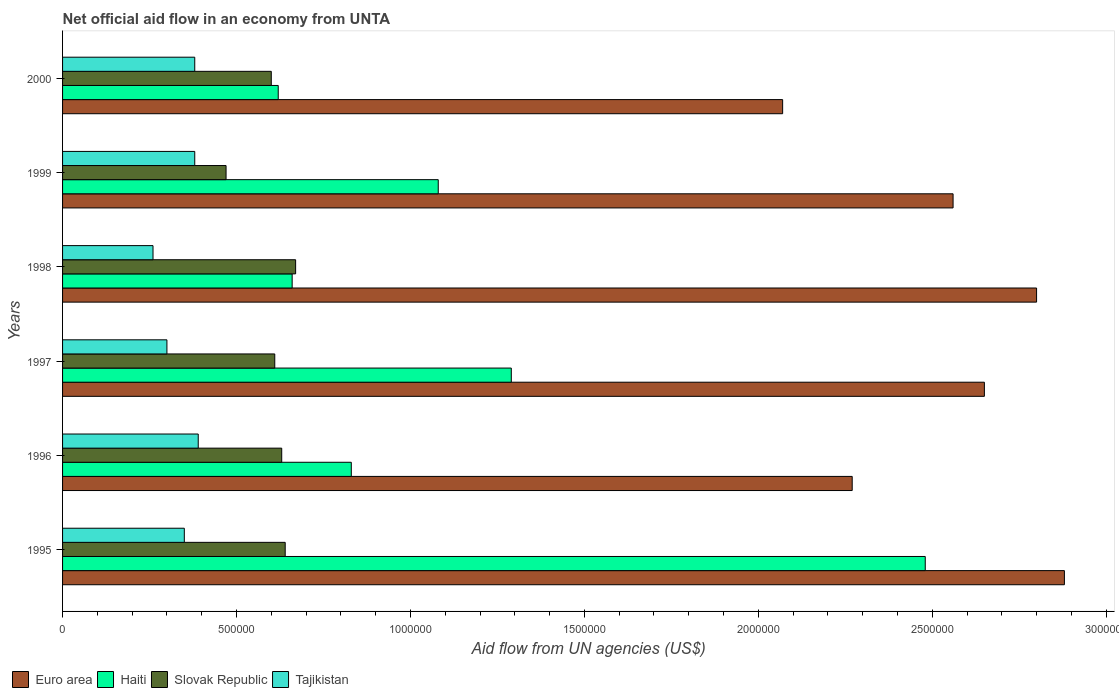How many different coloured bars are there?
Offer a terse response. 4. How many groups of bars are there?
Give a very brief answer. 6. Are the number of bars per tick equal to the number of legend labels?
Offer a very short reply. Yes. How many bars are there on the 4th tick from the top?
Your answer should be very brief. 4. How many bars are there on the 6th tick from the bottom?
Your answer should be compact. 4. What is the label of the 2nd group of bars from the top?
Your answer should be compact. 1999. What is the net official aid flow in Haiti in 1995?
Offer a terse response. 2.48e+06. Across all years, what is the maximum net official aid flow in Tajikistan?
Give a very brief answer. 3.90e+05. Across all years, what is the minimum net official aid flow in Haiti?
Offer a very short reply. 6.20e+05. In which year was the net official aid flow in Haiti maximum?
Keep it short and to the point. 1995. What is the total net official aid flow in Slovak Republic in the graph?
Offer a very short reply. 3.62e+06. What is the difference between the net official aid flow in Euro area in 1996 and the net official aid flow in Haiti in 1998?
Provide a succinct answer. 1.61e+06. What is the average net official aid flow in Tajikistan per year?
Offer a very short reply. 3.43e+05. What is the ratio of the net official aid flow in Slovak Republic in 1998 to that in 2000?
Ensure brevity in your answer.  1.12. What is the difference between the highest and the second highest net official aid flow in Euro area?
Offer a terse response. 8.00e+04. What is the difference between the highest and the lowest net official aid flow in Tajikistan?
Give a very brief answer. 1.30e+05. Is the sum of the net official aid flow in Slovak Republic in 1995 and 1998 greater than the maximum net official aid flow in Haiti across all years?
Ensure brevity in your answer.  No. Is it the case that in every year, the sum of the net official aid flow in Slovak Republic and net official aid flow in Tajikistan is greater than the sum of net official aid flow in Euro area and net official aid flow in Haiti?
Make the answer very short. Yes. What does the 3rd bar from the top in 1999 represents?
Provide a short and direct response. Haiti. What does the 4th bar from the bottom in 2000 represents?
Keep it short and to the point. Tajikistan. What is the difference between two consecutive major ticks on the X-axis?
Ensure brevity in your answer.  5.00e+05. Does the graph contain any zero values?
Your response must be concise. No. How are the legend labels stacked?
Keep it short and to the point. Horizontal. What is the title of the graph?
Provide a short and direct response. Net official aid flow in an economy from UNTA. Does "Malta" appear as one of the legend labels in the graph?
Make the answer very short. No. What is the label or title of the X-axis?
Your answer should be very brief. Aid flow from UN agencies (US$). What is the Aid flow from UN agencies (US$) in Euro area in 1995?
Provide a short and direct response. 2.88e+06. What is the Aid flow from UN agencies (US$) in Haiti in 1995?
Give a very brief answer. 2.48e+06. What is the Aid flow from UN agencies (US$) of Slovak Republic in 1995?
Provide a short and direct response. 6.40e+05. What is the Aid flow from UN agencies (US$) of Euro area in 1996?
Make the answer very short. 2.27e+06. What is the Aid flow from UN agencies (US$) in Haiti in 1996?
Offer a terse response. 8.30e+05. What is the Aid flow from UN agencies (US$) of Slovak Republic in 1996?
Provide a succinct answer. 6.30e+05. What is the Aid flow from UN agencies (US$) of Tajikistan in 1996?
Keep it short and to the point. 3.90e+05. What is the Aid flow from UN agencies (US$) of Euro area in 1997?
Provide a short and direct response. 2.65e+06. What is the Aid flow from UN agencies (US$) in Haiti in 1997?
Your answer should be very brief. 1.29e+06. What is the Aid flow from UN agencies (US$) in Tajikistan in 1997?
Make the answer very short. 3.00e+05. What is the Aid flow from UN agencies (US$) in Euro area in 1998?
Give a very brief answer. 2.80e+06. What is the Aid flow from UN agencies (US$) in Slovak Republic in 1998?
Your answer should be compact. 6.70e+05. What is the Aid flow from UN agencies (US$) of Tajikistan in 1998?
Your response must be concise. 2.60e+05. What is the Aid flow from UN agencies (US$) of Euro area in 1999?
Make the answer very short. 2.56e+06. What is the Aid flow from UN agencies (US$) of Haiti in 1999?
Give a very brief answer. 1.08e+06. What is the Aid flow from UN agencies (US$) in Slovak Republic in 1999?
Your answer should be very brief. 4.70e+05. What is the Aid flow from UN agencies (US$) in Euro area in 2000?
Your answer should be very brief. 2.07e+06. What is the Aid flow from UN agencies (US$) of Haiti in 2000?
Make the answer very short. 6.20e+05. Across all years, what is the maximum Aid flow from UN agencies (US$) of Euro area?
Offer a terse response. 2.88e+06. Across all years, what is the maximum Aid flow from UN agencies (US$) in Haiti?
Keep it short and to the point. 2.48e+06. Across all years, what is the maximum Aid flow from UN agencies (US$) of Slovak Republic?
Give a very brief answer. 6.70e+05. Across all years, what is the maximum Aid flow from UN agencies (US$) in Tajikistan?
Keep it short and to the point. 3.90e+05. Across all years, what is the minimum Aid flow from UN agencies (US$) in Euro area?
Offer a very short reply. 2.07e+06. Across all years, what is the minimum Aid flow from UN agencies (US$) in Haiti?
Make the answer very short. 6.20e+05. Across all years, what is the minimum Aid flow from UN agencies (US$) in Slovak Republic?
Keep it short and to the point. 4.70e+05. What is the total Aid flow from UN agencies (US$) in Euro area in the graph?
Your response must be concise. 1.52e+07. What is the total Aid flow from UN agencies (US$) in Haiti in the graph?
Your answer should be very brief. 6.96e+06. What is the total Aid flow from UN agencies (US$) of Slovak Republic in the graph?
Your answer should be compact. 3.62e+06. What is the total Aid flow from UN agencies (US$) in Tajikistan in the graph?
Your response must be concise. 2.06e+06. What is the difference between the Aid flow from UN agencies (US$) in Haiti in 1995 and that in 1996?
Your answer should be compact. 1.65e+06. What is the difference between the Aid flow from UN agencies (US$) of Euro area in 1995 and that in 1997?
Give a very brief answer. 2.30e+05. What is the difference between the Aid flow from UN agencies (US$) in Haiti in 1995 and that in 1997?
Offer a very short reply. 1.19e+06. What is the difference between the Aid flow from UN agencies (US$) in Tajikistan in 1995 and that in 1997?
Offer a terse response. 5.00e+04. What is the difference between the Aid flow from UN agencies (US$) of Haiti in 1995 and that in 1998?
Your answer should be very brief. 1.82e+06. What is the difference between the Aid flow from UN agencies (US$) of Euro area in 1995 and that in 1999?
Offer a terse response. 3.20e+05. What is the difference between the Aid flow from UN agencies (US$) in Haiti in 1995 and that in 1999?
Keep it short and to the point. 1.40e+06. What is the difference between the Aid flow from UN agencies (US$) of Slovak Republic in 1995 and that in 1999?
Your response must be concise. 1.70e+05. What is the difference between the Aid flow from UN agencies (US$) of Euro area in 1995 and that in 2000?
Make the answer very short. 8.10e+05. What is the difference between the Aid flow from UN agencies (US$) in Haiti in 1995 and that in 2000?
Your answer should be very brief. 1.86e+06. What is the difference between the Aid flow from UN agencies (US$) in Euro area in 1996 and that in 1997?
Your answer should be very brief. -3.80e+05. What is the difference between the Aid flow from UN agencies (US$) of Haiti in 1996 and that in 1997?
Offer a terse response. -4.60e+05. What is the difference between the Aid flow from UN agencies (US$) of Euro area in 1996 and that in 1998?
Give a very brief answer. -5.30e+05. What is the difference between the Aid flow from UN agencies (US$) in Haiti in 1996 and that in 1999?
Keep it short and to the point. -2.50e+05. What is the difference between the Aid flow from UN agencies (US$) in Tajikistan in 1996 and that in 1999?
Provide a succinct answer. 10000. What is the difference between the Aid flow from UN agencies (US$) in Slovak Republic in 1996 and that in 2000?
Offer a terse response. 3.00e+04. What is the difference between the Aid flow from UN agencies (US$) in Tajikistan in 1996 and that in 2000?
Offer a very short reply. 10000. What is the difference between the Aid flow from UN agencies (US$) of Euro area in 1997 and that in 1998?
Offer a terse response. -1.50e+05. What is the difference between the Aid flow from UN agencies (US$) in Haiti in 1997 and that in 1998?
Keep it short and to the point. 6.30e+05. What is the difference between the Aid flow from UN agencies (US$) of Slovak Republic in 1997 and that in 1998?
Provide a short and direct response. -6.00e+04. What is the difference between the Aid flow from UN agencies (US$) in Tajikistan in 1997 and that in 1998?
Offer a very short reply. 4.00e+04. What is the difference between the Aid flow from UN agencies (US$) in Euro area in 1997 and that in 1999?
Provide a succinct answer. 9.00e+04. What is the difference between the Aid flow from UN agencies (US$) in Haiti in 1997 and that in 1999?
Give a very brief answer. 2.10e+05. What is the difference between the Aid flow from UN agencies (US$) in Slovak Republic in 1997 and that in 1999?
Offer a very short reply. 1.40e+05. What is the difference between the Aid flow from UN agencies (US$) in Euro area in 1997 and that in 2000?
Keep it short and to the point. 5.80e+05. What is the difference between the Aid flow from UN agencies (US$) in Haiti in 1997 and that in 2000?
Your answer should be compact. 6.70e+05. What is the difference between the Aid flow from UN agencies (US$) of Slovak Republic in 1997 and that in 2000?
Ensure brevity in your answer.  10000. What is the difference between the Aid flow from UN agencies (US$) in Tajikistan in 1997 and that in 2000?
Provide a short and direct response. -8.00e+04. What is the difference between the Aid flow from UN agencies (US$) of Haiti in 1998 and that in 1999?
Make the answer very short. -4.20e+05. What is the difference between the Aid flow from UN agencies (US$) of Slovak Republic in 1998 and that in 1999?
Give a very brief answer. 2.00e+05. What is the difference between the Aid flow from UN agencies (US$) in Tajikistan in 1998 and that in 1999?
Your answer should be very brief. -1.20e+05. What is the difference between the Aid flow from UN agencies (US$) of Euro area in 1998 and that in 2000?
Provide a succinct answer. 7.30e+05. What is the difference between the Aid flow from UN agencies (US$) of Haiti in 1998 and that in 2000?
Make the answer very short. 4.00e+04. What is the difference between the Aid flow from UN agencies (US$) in Euro area in 1999 and that in 2000?
Give a very brief answer. 4.90e+05. What is the difference between the Aid flow from UN agencies (US$) of Slovak Republic in 1999 and that in 2000?
Provide a succinct answer. -1.30e+05. What is the difference between the Aid flow from UN agencies (US$) in Tajikistan in 1999 and that in 2000?
Give a very brief answer. 0. What is the difference between the Aid flow from UN agencies (US$) of Euro area in 1995 and the Aid flow from UN agencies (US$) of Haiti in 1996?
Keep it short and to the point. 2.05e+06. What is the difference between the Aid flow from UN agencies (US$) of Euro area in 1995 and the Aid flow from UN agencies (US$) of Slovak Republic in 1996?
Provide a short and direct response. 2.25e+06. What is the difference between the Aid flow from UN agencies (US$) in Euro area in 1995 and the Aid flow from UN agencies (US$) in Tajikistan in 1996?
Keep it short and to the point. 2.49e+06. What is the difference between the Aid flow from UN agencies (US$) of Haiti in 1995 and the Aid flow from UN agencies (US$) of Slovak Republic in 1996?
Keep it short and to the point. 1.85e+06. What is the difference between the Aid flow from UN agencies (US$) of Haiti in 1995 and the Aid flow from UN agencies (US$) of Tajikistan in 1996?
Ensure brevity in your answer.  2.09e+06. What is the difference between the Aid flow from UN agencies (US$) in Slovak Republic in 1995 and the Aid flow from UN agencies (US$) in Tajikistan in 1996?
Give a very brief answer. 2.50e+05. What is the difference between the Aid flow from UN agencies (US$) of Euro area in 1995 and the Aid flow from UN agencies (US$) of Haiti in 1997?
Your response must be concise. 1.59e+06. What is the difference between the Aid flow from UN agencies (US$) in Euro area in 1995 and the Aid flow from UN agencies (US$) in Slovak Republic in 1997?
Make the answer very short. 2.27e+06. What is the difference between the Aid flow from UN agencies (US$) in Euro area in 1995 and the Aid flow from UN agencies (US$) in Tajikistan in 1997?
Offer a very short reply. 2.58e+06. What is the difference between the Aid flow from UN agencies (US$) of Haiti in 1995 and the Aid flow from UN agencies (US$) of Slovak Republic in 1997?
Provide a short and direct response. 1.87e+06. What is the difference between the Aid flow from UN agencies (US$) in Haiti in 1995 and the Aid flow from UN agencies (US$) in Tajikistan in 1997?
Make the answer very short. 2.18e+06. What is the difference between the Aid flow from UN agencies (US$) in Slovak Republic in 1995 and the Aid flow from UN agencies (US$) in Tajikistan in 1997?
Offer a terse response. 3.40e+05. What is the difference between the Aid flow from UN agencies (US$) in Euro area in 1995 and the Aid flow from UN agencies (US$) in Haiti in 1998?
Ensure brevity in your answer.  2.22e+06. What is the difference between the Aid flow from UN agencies (US$) in Euro area in 1995 and the Aid flow from UN agencies (US$) in Slovak Republic in 1998?
Your answer should be compact. 2.21e+06. What is the difference between the Aid flow from UN agencies (US$) of Euro area in 1995 and the Aid flow from UN agencies (US$) of Tajikistan in 1998?
Provide a short and direct response. 2.62e+06. What is the difference between the Aid flow from UN agencies (US$) of Haiti in 1995 and the Aid flow from UN agencies (US$) of Slovak Republic in 1998?
Offer a terse response. 1.81e+06. What is the difference between the Aid flow from UN agencies (US$) in Haiti in 1995 and the Aid flow from UN agencies (US$) in Tajikistan in 1998?
Your answer should be compact. 2.22e+06. What is the difference between the Aid flow from UN agencies (US$) of Slovak Republic in 1995 and the Aid flow from UN agencies (US$) of Tajikistan in 1998?
Offer a terse response. 3.80e+05. What is the difference between the Aid flow from UN agencies (US$) of Euro area in 1995 and the Aid flow from UN agencies (US$) of Haiti in 1999?
Your response must be concise. 1.80e+06. What is the difference between the Aid flow from UN agencies (US$) in Euro area in 1995 and the Aid flow from UN agencies (US$) in Slovak Republic in 1999?
Provide a succinct answer. 2.41e+06. What is the difference between the Aid flow from UN agencies (US$) in Euro area in 1995 and the Aid flow from UN agencies (US$) in Tajikistan in 1999?
Give a very brief answer. 2.50e+06. What is the difference between the Aid flow from UN agencies (US$) of Haiti in 1995 and the Aid flow from UN agencies (US$) of Slovak Republic in 1999?
Ensure brevity in your answer.  2.01e+06. What is the difference between the Aid flow from UN agencies (US$) of Haiti in 1995 and the Aid flow from UN agencies (US$) of Tajikistan in 1999?
Your answer should be compact. 2.10e+06. What is the difference between the Aid flow from UN agencies (US$) of Euro area in 1995 and the Aid flow from UN agencies (US$) of Haiti in 2000?
Give a very brief answer. 2.26e+06. What is the difference between the Aid flow from UN agencies (US$) of Euro area in 1995 and the Aid flow from UN agencies (US$) of Slovak Republic in 2000?
Your answer should be very brief. 2.28e+06. What is the difference between the Aid flow from UN agencies (US$) of Euro area in 1995 and the Aid flow from UN agencies (US$) of Tajikistan in 2000?
Offer a very short reply. 2.50e+06. What is the difference between the Aid flow from UN agencies (US$) of Haiti in 1995 and the Aid flow from UN agencies (US$) of Slovak Republic in 2000?
Ensure brevity in your answer.  1.88e+06. What is the difference between the Aid flow from UN agencies (US$) of Haiti in 1995 and the Aid flow from UN agencies (US$) of Tajikistan in 2000?
Your answer should be very brief. 2.10e+06. What is the difference between the Aid flow from UN agencies (US$) of Euro area in 1996 and the Aid flow from UN agencies (US$) of Haiti in 1997?
Provide a short and direct response. 9.80e+05. What is the difference between the Aid flow from UN agencies (US$) of Euro area in 1996 and the Aid flow from UN agencies (US$) of Slovak Republic in 1997?
Your answer should be very brief. 1.66e+06. What is the difference between the Aid flow from UN agencies (US$) of Euro area in 1996 and the Aid flow from UN agencies (US$) of Tajikistan in 1997?
Provide a short and direct response. 1.97e+06. What is the difference between the Aid flow from UN agencies (US$) in Haiti in 1996 and the Aid flow from UN agencies (US$) in Tajikistan in 1997?
Give a very brief answer. 5.30e+05. What is the difference between the Aid flow from UN agencies (US$) of Slovak Republic in 1996 and the Aid flow from UN agencies (US$) of Tajikistan in 1997?
Provide a succinct answer. 3.30e+05. What is the difference between the Aid flow from UN agencies (US$) in Euro area in 1996 and the Aid flow from UN agencies (US$) in Haiti in 1998?
Your answer should be very brief. 1.61e+06. What is the difference between the Aid flow from UN agencies (US$) in Euro area in 1996 and the Aid flow from UN agencies (US$) in Slovak Republic in 1998?
Your answer should be compact. 1.60e+06. What is the difference between the Aid flow from UN agencies (US$) in Euro area in 1996 and the Aid flow from UN agencies (US$) in Tajikistan in 1998?
Ensure brevity in your answer.  2.01e+06. What is the difference between the Aid flow from UN agencies (US$) of Haiti in 1996 and the Aid flow from UN agencies (US$) of Slovak Republic in 1998?
Provide a succinct answer. 1.60e+05. What is the difference between the Aid flow from UN agencies (US$) in Haiti in 1996 and the Aid flow from UN agencies (US$) in Tajikistan in 1998?
Make the answer very short. 5.70e+05. What is the difference between the Aid flow from UN agencies (US$) in Euro area in 1996 and the Aid flow from UN agencies (US$) in Haiti in 1999?
Provide a short and direct response. 1.19e+06. What is the difference between the Aid flow from UN agencies (US$) of Euro area in 1996 and the Aid flow from UN agencies (US$) of Slovak Republic in 1999?
Give a very brief answer. 1.80e+06. What is the difference between the Aid flow from UN agencies (US$) in Euro area in 1996 and the Aid flow from UN agencies (US$) in Tajikistan in 1999?
Keep it short and to the point. 1.89e+06. What is the difference between the Aid flow from UN agencies (US$) in Haiti in 1996 and the Aid flow from UN agencies (US$) in Tajikistan in 1999?
Make the answer very short. 4.50e+05. What is the difference between the Aid flow from UN agencies (US$) in Slovak Republic in 1996 and the Aid flow from UN agencies (US$) in Tajikistan in 1999?
Your answer should be very brief. 2.50e+05. What is the difference between the Aid flow from UN agencies (US$) in Euro area in 1996 and the Aid flow from UN agencies (US$) in Haiti in 2000?
Provide a succinct answer. 1.65e+06. What is the difference between the Aid flow from UN agencies (US$) of Euro area in 1996 and the Aid flow from UN agencies (US$) of Slovak Republic in 2000?
Provide a succinct answer. 1.67e+06. What is the difference between the Aid flow from UN agencies (US$) of Euro area in 1996 and the Aid flow from UN agencies (US$) of Tajikistan in 2000?
Your response must be concise. 1.89e+06. What is the difference between the Aid flow from UN agencies (US$) in Haiti in 1996 and the Aid flow from UN agencies (US$) in Tajikistan in 2000?
Provide a succinct answer. 4.50e+05. What is the difference between the Aid flow from UN agencies (US$) of Euro area in 1997 and the Aid flow from UN agencies (US$) of Haiti in 1998?
Offer a terse response. 1.99e+06. What is the difference between the Aid flow from UN agencies (US$) in Euro area in 1997 and the Aid flow from UN agencies (US$) in Slovak Republic in 1998?
Ensure brevity in your answer.  1.98e+06. What is the difference between the Aid flow from UN agencies (US$) of Euro area in 1997 and the Aid flow from UN agencies (US$) of Tajikistan in 1998?
Your response must be concise. 2.39e+06. What is the difference between the Aid flow from UN agencies (US$) of Haiti in 1997 and the Aid flow from UN agencies (US$) of Slovak Republic in 1998?
Give a very brief answer. 6.20e+05. What is the difference between the Aid flow from UN agencies (US$) of Haiti in 1997 and the Aid flow from UN agencies (US$) of Tajikistan in 1998?
Offer a terse response. 1.03e+06. What is the difference between the Aid flow from UN agencies (US$) of Slovak Republic in 1997 and the Aid flow from UN agencies (US$) of Tajikistan in 1998?
Make the answer very short. 3.50e+05. What is the difference between the Aid flow from UN agencies (US$) in Euro area in 1997 and the Aid flow from UN agencies (US$) in Haiti in 1999?
Your response must be concise. 1.57e+06. What is the difference between the Aid flow from UN agencies (US$) in Euro area in 1997 and the Aid flow from UN agencies (US$) in Slovak Republic in 1999?
Your answer should be compact. 2.18e+06. What is the difference between the Aid flow from UN agencies (US$) in Euro area in 1997 and the Aid flow from UN agencies (US$) in Tajikistan in 1999?
Provide a short and direct response. 2.27e+06. What is the difference between the Aid flow from UN agencies (US$) of Haiti in 1997 and the Aid flow from UN agencies (US$) of Slovak Republic in 1999?
Keep it short and to the point. 8.20e+05. What is the difference between the Aid flow from UN agencies (US$) of Haiti in 1997 and the Aid flow from UN agencies (US$) of Tajikistan in 1999?
Make the answer very short. 9.10e+05. What is the difference between the Aid flow from UN agencies (US$) in Slovak Republic in 1997 and the Aid flow from UN agencies (US$) in Tajikistan in 1999?
Provide a short and direct response. 2.30e+05. What is the difference between the Aid flow from UN agencies (US$) in Euro area in 1997 and the Aid flow from UN agencies (US$) in Haiti in 2000?
Offer a very short reply. 2.03e+06. What is the difference between the Aid flow from UN agencies (US$) of Euro area in 1997 and the Aid flow from UN agencies (US$) of Slovak Republic in 2000?
Offer a very short reply. 2.05e+06. What is the difference between the Aid flow from UN agencies (US$) in Euro area in 1997 and the Aid flow from UN agencies (US$) in Tajikistan in 2000?
Your response must be concise. 2.27e+06. What is the difference between the Aid flow from UN agencies (US$) in Haiti in 1997 and the Aid flow from UN agencies (US$) in Slovak Republic in 2000?
Keep it short and to the point. 6.90e+05. What is the difference between the Aid flow from UN agencies (US$) in Haiti in 1997 and the Aid flow from UN agencies (US$) in Tajikistan in 2000?
Ensure brevity in your answer.  9.10e+05. What is the difference between the Aid flow from UN agencies (US$) in Slovak Republic in 1997 and the Aid flow from UN agencies (US$) in Tajikistan in 2000?
Give a very brief answer. 2.30e+05. What is the difference between the Aid flow from UN agencies (US$) in Euro area in 1998 and the Aid flow from UN agencies (US$) in Haiti in 1999?
Provide a short and direct response. 1.72e+06. What is the difference between the Aid flow from UN agencies (US$) of Euro area in 1998 and the Aid flow from UN agencies (US$) of Slovak Republic in 1999?
Offer a terse response. 2.33e+06. What is the difference between the Aid flow from UN agencies (US$) in Euro area in 1998 and the Aid flow from UN agencies (US$) in Tajikistan in 1999?
Provide a succinct answer. 2.42e+06. What is the difference between the Aid flow from UN agencies (US$) of Haiti in 1998 and the Aid flow from UN agencies (US$) of Tajikistan in 1999?
Provide a succinct answer. 2.80e+05. What is the difference between the Aid flow from UN agencies (US$) of Euro area in 1998 and the Aid flow from UN agencies (US$) of Haiti in 2000?
Offer a very short reply. 2.18e+06. What is the difference between the Aid flow from UN agencies (US$) of Euro area in 1998 and the Aid flow from UN agencies (US$) of Slovak Republic in 2000?
Make the answer very short. 2.20e+06. What is the difference between the Aid flow from UN agencies (US$) of Euro area in 1998 and the Aid flow from UN agencies (US$) of Tajikistan in 2000?
Make the answer very short. 2.42e+06. What is the difference between the Aid flow from UN agencies (US$) of Euro area in 1999 and the Aid flow from UN agencies (US$) of Haiti in 2000?
Your answer should be very brief. 1.94e+06. What is the difference between the Aid flow from UN agencies (US$) of Euro area in 1999 and the Aid flow from UN agencies (US$) of Slovak Republic in 2000?
Give a very brief answer. 1.96e+06. What is the difference between the Aid flow from UN agencies (US$) of Euro area in 1999 and the Aid flow from UN agencies (US$) of Tajikistan in 2000?
Give a very brief answer. 2.18e+06. What is the difference between the Aid flow from UN agencies (US$) in Haiti in 1999 and the Aid flow from UN agencies (US$) in Slovak Republic in 2000?
Make the answer very short. 4.80e+05. What is the difference between the Aid flow from UN agencies (US$) in Haiti in 1999 and the Aid flow from UN agencies (US$) in Tajikistan in 2000?
Your answer should be compact. 7.00e+05. What is the difference between the Aid flow from UN agencies (US$) of Slovak Republic in 1999 and the Aid flow from UN agencies (US$) of Tajikistan in 2000?
Provide a short and direct response. 9.00e+04. What is the average Aid flow from UN agencies (US$) of Euro area per year?
Offer a very short reply. 2.54e+06. What is the average Aid flow from UN agencies (US$) in Haiti per year?
Your response must be concise. 1.16e+06. What is the average Aid flow from UN agencies (US$) in Slovak Republic per year?
Make the answer very short. 6.03e+05. What is the average Aid flow from UN agencies (US$) of Tajikistan per year?
Ensure brevity in your answer.  3.43e+05. In the year 1995, what is the difference between the Aid flow from UN agencies (US$) in Euro area and Aid flow from UN agencies (US$) in Slovak Republic?
Keep it short and to the point. 2.24e+06. In the year 1995, what is the difference between the Aid flow from UN agencies (US$) in Euro area and Aid flow from UN agencies (US$) in Tajikistan?
Ensure brevity in your answer.  2.53e+06. In the year 1995, what is the difference between the Aid flow from UN agencies (US$) in Haiti and Aid flow from UN agencies (US$) in Slovak Republic?
Ensure brevity in your answer.  1.84e+06. In the year 1995, what is the difference between the Aid flow from UN agencies (US$) of Haiti and Aid flow from UN agencies (US$) of Tajikistan?
Offer a very short reply. 2.13e+06. In the year 1996, what is the difference between the Aid flow from UN agencies (US$) of Euro area and Aid flow from UN agencies (US$) of Haiti?
Ensure brevity in your answer.  1.44e+06. In the year 1996, what is the difference between the Aid flow from UN agencies (US$) of Euro area and Aid flow from UN agencies (US$) of Slovak Republic?
Provide a short and direct response. 1.64e+06. In the year 1996, what is the difference between the Aid flow from UN agencies (US$) of Euro area and Aid flow from UN agencies (US$) of Tajikistan?
Ensure brevity in your answer.  1.88e+06. In the year 1996, what is the difference between the Aid flow from UN agencies (US$) of Haiti and Aid flow from UN agencies (US$) of Slovak Republic?
Provide a short and direct response. 2.00e+05. In the year 1996, what is the difference between the Aid flow from UN agencies (US$) in Haiti and Aid flow from UN agencies (US$) in Tajikistan?
Keep it short and to the point. 4.40e+05. In the year 1997, what is the difference between the Aid flow from UN agencies (US$) of Euro area and Aid flow from UN agencies (US$) of Haiti?
Ensure brevity in your answer.  1.36e+06. In the year 1997, what is the difference between the Aid flow from UN agencies (US$) of Euro area and Aid flow from UN agencies (US$) of Slovak Republic?
Give a very brief answer. 2.04e+06. In the year 1997, what is the difference between the Aid flow from UN agencies (US$) of Euro area and Aid flow from UN agencies (US$) of Tajikistan?
Provide a short and direct response. 2.35e+06. In the year 1997, what is the difference between the Aid flow from UN agencies (US$) in Haiti and Aid flow from UN agencies (US$) in Slovak Republic?
Ensure brevity in your answer.  6.80e+05. In the year 1997, what is the difference between the Aid flow from UN agencies (US$) of Haiti and Aid flow from UN agencies (US$) of Tajikistan?
Your answer should be very brief. 9.90e+05. In the year 1998, what is the difference between the Aid flow from UN agencies (US$) of Euro area and Aid flow from UN agencies (US$) of Haiti?
Offer a very short reply. 2.14e+06. In the year 1998, what is the difference between the Aid flow from UN agencies (US$) of Euro area and Aid flow from UN agencies (US$) of Slovak Republic?
Ensure brevity in your answer.  2.13e+06. In the year 1998, what is the difference between the Aid flow from UN agencies (US$) in Euro area and Aid flow from UN agencies (US$) in Tajikistan?
Your answer should be very brief. 2.54e+06. In the year 1998, what is the difference between the Aid flow from UN agencies (US$) of Haiti and Aid flow from UN agencies (US$) of Tajikistan?
Give a very brief answer. 4.00e+05. In the year 1998, what is the difference between the Aid flow from UN agencies (US$) in Slovak Republic and Aid flow from UN agencies (US$) in Tajikistan?
Your answer should be compact. 4.10e+05. In the year 1999, what is the difference between the Aid flow from UN agencies (US$) in Euro area and Aid flow from UN agencies (US$) in Haiti?
Make the answer very short. 1.48e+06. In the year 1999, what is the difference between the Aid flow from UN agencies (US$) in Euro area and Aid flow from UN agencies (US$) in Slovak Republic?
Provide a succinct answer. 2.09e+06. In the year 1999, what is the difference between the Aid flow from UN agencies (US$) of Euro area and Aid flow from UN agencies (US$) of Tajikistan?
Make the answer very short. 2.18e+06. In the year 2000, what is the difference between the Aid flow from UN agencies (US$) in Euro area and Aid flow from UN agencies (US$) in Haiti?
Provide a short and direct response. 1.45e+06. In the year 2000, what is the difference between the Aid flow from UN agencies (US$) in Euro area and Aid flow from UN agencies (US$) in Slovak Republic?
Offer a very short reply. 1.47e+06. In the year 2000, what is the difference between the Aid flow from UN agencies (US$) of Euro area and Aid flow from UN agencies (US$) of Tajikistan?
Your answer should be compact. 1.69e+06. In the year 2000, what is the difference between the Aid flow from UN agencies (US$) in Haiti and Aid flow from UN agencies (US$) in Slovak Republic?
Keep it short and to the point. 2.00e+04. In the year 2000, what is the difference between the Aid flow from UN agencies (US$) in Haiti and Aid flow from UN agencies (US$) in Tajikistan?
Your answer should be very brief. 2.40e+05. In the year 2000, what is the difference between the Aid flow from UN agencies (US$) of Slovak Republic and Aid flow from UN agencies (US$) of Tajikistan?
Provide a short and direct response. 2.20e+05. What is the ratio of the Aid flow from UN agencies (US$) in Euro area in 1995 to that in 1996?
Offer a very short reply. 1.27. What is the ratio of the Aid flow from UN agencies (US$) in Haiti in 1995 to that in 1996?
Your answer should be very brief. 2.99. What is the ratio of the Aid flow from UN agencies (US$) in Slovak Republic in 1995 to that in 1996?
Your answer should be compact. 1.02. What is the ratio of the Aid flow from UN agencies (US$) in Tajikistan in 1995 to that in 1996?
Make the answer very short. 0.9. What is the ratio of the Aid flow from UN agencies (US$) of Euro area in 1995 to that in 1997?
Ensure brevity in your answer.  1.09. What is the ratio of the Aid flow from UN agencies (US$) of Haiti in 1995 to that in 1997?
Offer a terse response. 1.92. What is the ratio of the Aid flow from UN agencies (US$) in Slovak Republic in 1995 to that in 1997?
Your answer should be compact. 1.05. What is the ratio of the Aid flow from UN agencies (US$) of Euro area in 1995 to that in 1998?
Give a very brief answer. 1.03. What is the ratio of the Aid flow from UN agencies (US$) in Haiti in 1995 to that in 1998?
Give a very brief answer. 3.76. What is the ratio of the Aid flow from UN agencies (US$) of Slovak Republic in 1995 to that in 1998?
Offer a very short reply. 0.96. What is the ratio of the Aid flow from UN agencies (US$) of Tajikistan in 1995 to that in 1998?
Offer a very short reply. 1.35. What is the ratio of the Aid flow from UN agencies (US$) of Haiti in 1995 to that in 1999?
Provide a short and direct response. 2.3. What is the ratio of the Aid flow from UN agencies (US$) in Slovak Republic in 1995 to that in 1999?
Make the answer very short. 1.36. What is the ratio of the Aid flow from UN agencies (US$) in Tajikistan in 1995 to that in 1999?
Provide a succinct answer. 0.92. What is the ratio of the Aid flow from UN agencies (US$) of Euro area in 1995 to that in 2000?
Keep it short and to the point. 1.39. What is the ratio of the Aid flow from UN agencies (US$) of Haiti in 1995 to that in 2000?
Keep it short and to the point. 4. What is the ratio of the Aid flow from UN agencies (US$) of Slovak Republic in 1995 to that in 2000?
Your answer should be very brief. 1.07. What is the ratio of the Aid flow from UN agencies (US$) in Tajikistan in 1995 to that in 2000?
Your answer should be very brief. 0.92. What is the ratio of the Aid flow from UN agencies (US$) of Euro area in 1996 to that in 1997?
Your answer should be compact. 0.86. What is the ratio of the Aid flow from UN agencies (US$) in Haiti in 1996 to that in 1997?
Offer a terse response. 0.64. What is the ratio of the Aid flow from UN agencies (US$) in Slovak Republic in 1996 to that in 1997?
Provide a succinct answer. 1.03. What is the ratio of the Aid flow from UN agencies (US$) of Tajikistan in 1996 to that in 1997?
Ensure brevity in your answer.  1.3. What is the ratio of the Aid flow from UN agencies (US$) of Euro area in 1996 to that in 1998?
Your answer should be very brief. 0.81. What is the ratio of the Aid flow from UN agencies (US$) of Haiti in 1996 to that in 1998?
Give a very brief answer. 1.26. What is the ratio of the Aid flow from UN agencies (US$) in Slovak Republic in 1996 to that in 1998?
Ensure brevity in your answer.  0.94. What is the ratio of the Aid flow from UN agencies (US$) in Euro area in 1996 to that in 1999?
Your response must be concise. 0.89. What is the ratio of the Aid flow from UN agencies (US$) of Haiti in 1996 to that in 1999?
Your answer should be compact. 0.77. What is the ratio of the Aid flow from UN agencies (US$) in Slovak Republic in 1996 to that in 1999?
Ensure brevity in your answer.  1.34. What is the ratio of the Aid flow from UN agencies (US$) in Tajikistan in 1996 to that in 1999?
Ensure brevity in your answer.  1.03. What is the ratio of the Aid flow from UN agencies (US$) in Euro area in 1996 to that in 2000?
Provide a succinct answer. 1.1. What is the ratio of the Aid flow from UN agencies (US$) in Haiti in 1996 to that in 2000?
Give a very brief answer. 1.34. What is the ratio of the Aid flow from UN agencies (US$) in Tajikistan in 1996 to that in 2000?
Offer a very short reply. 1.03. What is the ratio of the Aid flow from UN agencies (US$) of Euro area in 1997 to that in 1998?
Your answer should be very brief. 0.95. What is the ratio of the Aid flow from UN agencies (US$) of Haiti in 1997 to that in 1998?
Offer a very short reply. 1.95. What is the ratio of the Aid flow from UN agencies (US$) in Slovak Republic in 1997 to that in 1998?
Ensure brevity in your answer.  0.91. What is the ratio of the Aid flow from UN agencies (US$) of Tajikistan in 1997 to that in 1998?
Offer a terse response. 1.15. What is the ratio of the Aid flow from UN agencies (US$) of Euro area in 1997 to that in 1999?
Ensure brevity in your answer.  1.04. What is the ratio of the Aid flow from UN agencies (US$) in Haiti in 1997 to that in 1999?
Offer a very short reply. 1.19. What is the ratio of the Aid flow from UN agencies (US$) in Slovak Republic in 1997 to that in 1999?
Provide a succinct answer. 1.3. What is the ratio of the Aid flow from UN agencies (US$) of Tajikistan in 1997 to that in 1999?
Give a very brief answer. 0.79. What is the ratio of the Aid flow from UN agencies (US$) of Euro area in 1997 to that in 2000?
Your answer should be compact. 1.28. What is the ratio of the Aid flow from UN agencies (US$) of Haiti in 1997 to that in 2000?
Ensure brevity in your answer.  2.08. What is the ratio of the Aid flow from UN agencies (US$) in Slovak Republic in 1997 to that in 2000?
Your response must be concise. 1.02. What is the ratio of the Aid flow from UN agencies (US$) in Tajikistan in 1997 to that in 2000?
Keep it short and to the point. 0.79. What is the ratio of the Aid flow from UN agencies (US$) of Euro area in 1998 to that in 1999?
Offer a very short reply. 1.09. What is the ratio of the Aid flow from UN agencies (US$) of Haiti in 1998 to that in 1999?
Your answer should be very brief. 0.61. What is the ratio of the Aid flow from UN agencies (US$) of Slovak Republic in 1998 to that in 1999?
Provide a short and direct response. 1.43. What is the ratio of the Aid flow from UN agencies (US$) of Tajikistan in 1998 to that in 1999?
Keep it short and to the point. 0.68. What is the ratio of the Aid flow from UN agencies (US$) of Euro area in 1998 to that in 2000?
Offer a very short reply. 1.35. What is the ratio of the Aid flow from UN agencies (US$) of Haiti in 1998 to that in 2000?
Keep it short and to the point. 1.06. What is the ratio of the Aid flow from UN agencies (US$) in Slovak Republic in 1998 to that in 2000?
Your answer should be compact. 1.12. What is the ratio of the Aid flow from UN agencies (US$) in Tajikistan in 1998 to that in 2000?
Make the answer very short. 0.68. What is the ratio of the Aid flow from UN agencies (US$) in Euro area in 1999 to that in 2000?
Make the answer very short. 1.24. What is the ratio of the Aid flow from UN agencies (US$) of Haiti in 1999 to that in 2000?
Keep it short and to the point. 1.74. What is the ratio of the Aid flow from UN agencies (US$) in Slovak Republic in 1999 to that in 2000?
Provide a succinct answer. 0.78. What is the ratio of the Aid flow from UN agencies (US$) of Tajikistan in 1999 to that in 2000?
Provide a short and direct response. 1. What is the difference between the highest and the second highest Aid flow from UN agencies (US$) of Haiti?
Your answer should be very brief. 1.19e+06. What is the difference between the highest and the second highest Aid flow from UN agencies (US$) in Tajikistan?
Your response must be concise. 10000. What is the difference between the highest and the lowest Aid flow from UN agencies (US$) of Euro area?
Provide a succinct answer. 8.10e+05. What is the difference between the highest and the lowest Aid flow from UN agencies (US$) in Haiti?
Provide a succinct answer. 1.86e+06. What is the difference between the highest and the lowest Aid flow from UN agencies (US$) in Tajikistan?
Your answer should be very brief. 1.30e+05. 